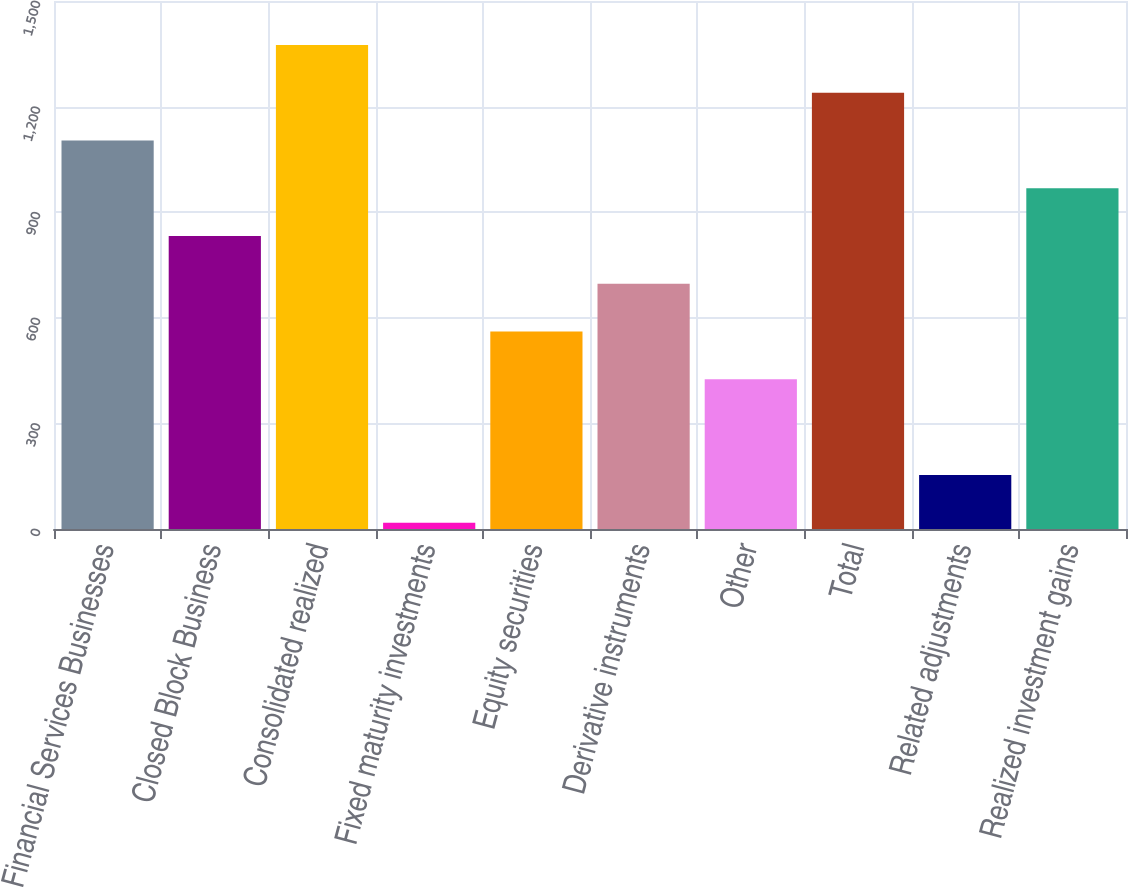Convert chart. <chart><loc_0><loc_0><loc_500><loc_500><bar_chart><fcel>Financial Services Businesses<fcel>Closed Block Business<fcel>Consolidated realized<fcel>Fixed maturity investments<fcel>Equity securities<fcel>Derivative instruments<fcel>Other<fcel>Total<fcel>Related adjustments<fcel>Realized investment gains<nl><fcel>1103.6<fcel>832.2<fcel>1375<fcel>18<fcel>560.8<fcel>696.5<fcel>425.1<fcel>1239.3<fcel>153.7<fcel>967.9<nl></chart> 